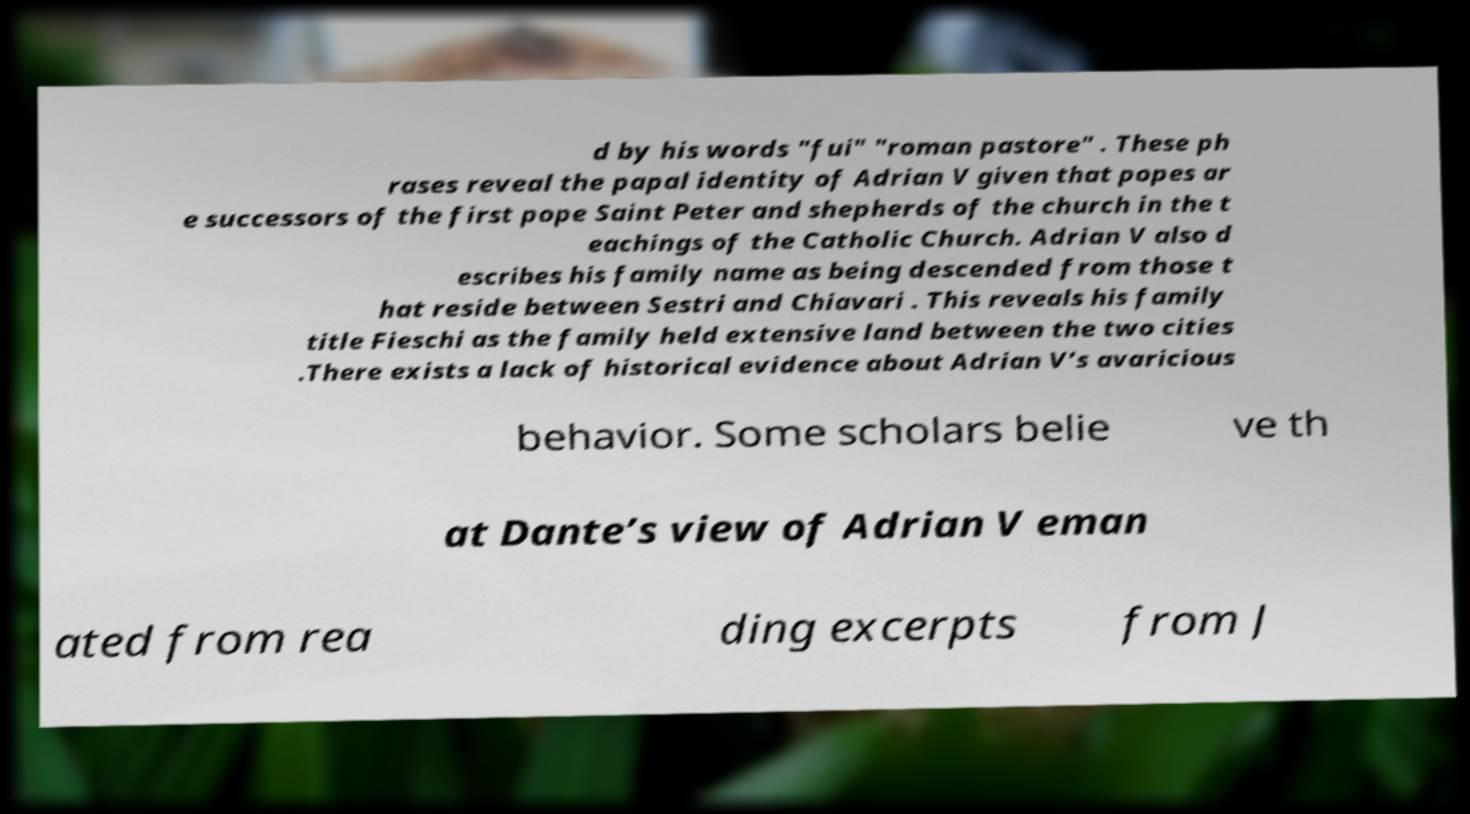There's text embedded in this image that I need extracted. Can you transcribe it verbatim? d by his words "fui" "roman pastore" . These ph rases reveal the papal identity of Adrian V given that popes ar e successors of the first pope Saint Peter and shepherds of the church in the t eachings of the Catholic Church. Adrian V also d escribes his family name as being descended from those t hat reside between Sestri and Chiavari . This reveals his family title Fieschi as the family held extensive land between the two cities .There exists a lack of historical evidence about Adrian V’s avaricious behavior. Some scholars belie ve th at Dante’s view of Adrian V eman ated from rea ding excerpts from J 